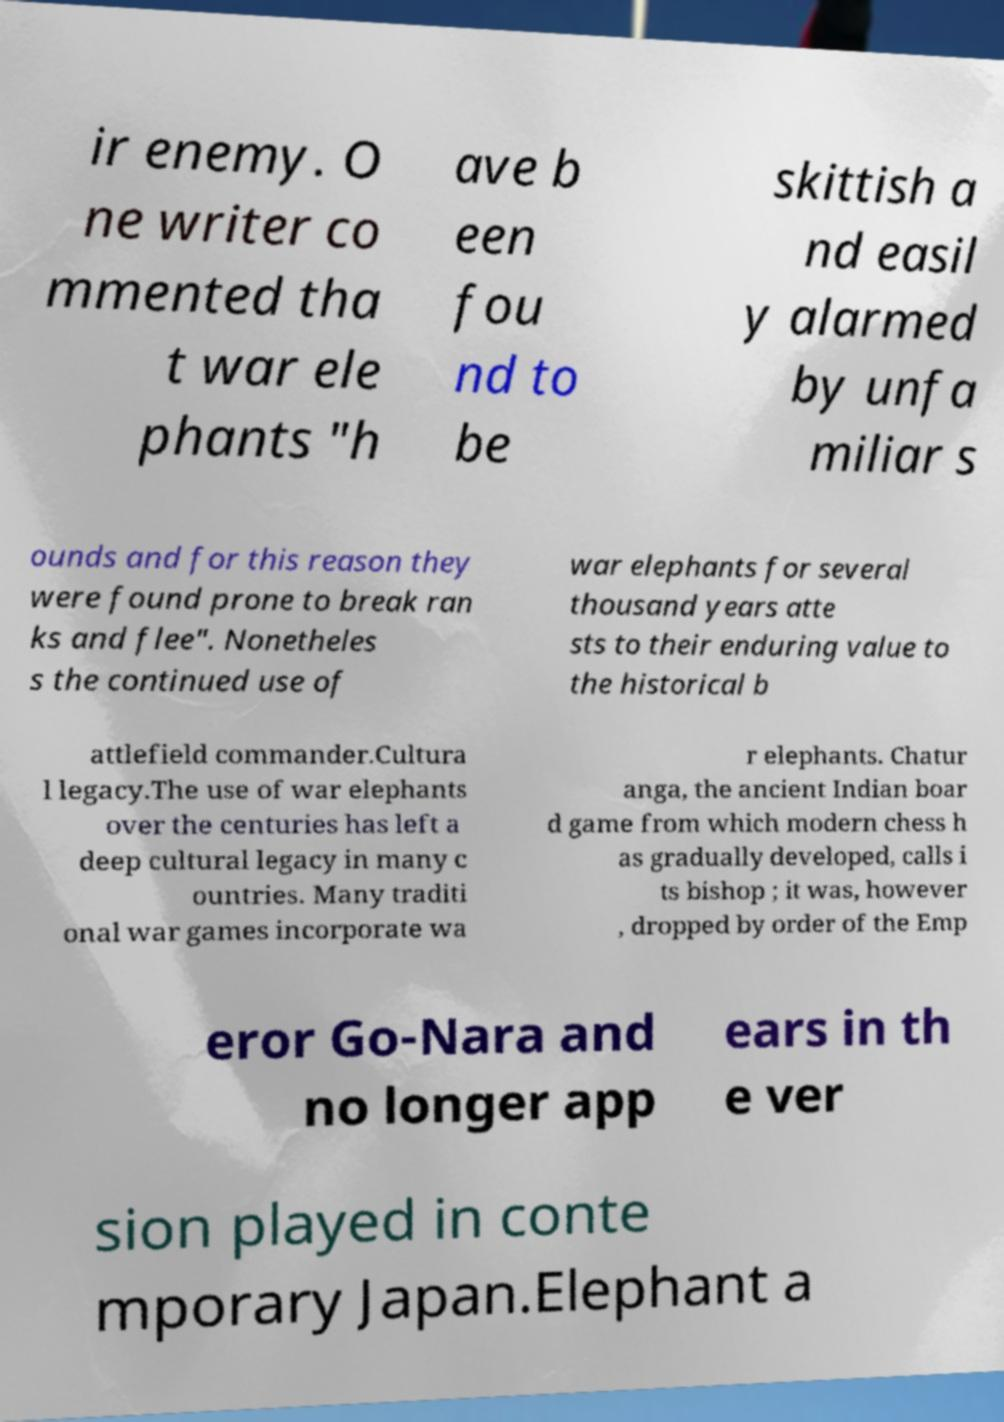Please read and relay the text visible in this image. What does it say? ir enemy. O ne writer co mmented tha t war ele phants "h ave b een fou nd to be skittish a nd easil y alarmed by unfa miliar s ounds and for this reason they were found prone to break ran ks and flee". Nonetheles s the continued use of war elephants for several thousand years atte sts to their enduring value to the historical b attlefield commander.Cultura l legacy.The use of war elephants over the centuries has left a deep cultural legacy in many c ountries. Many traditi onal war games incorporate wa r elephants. Chatur anga, the ancient Indian boar d game from which modern chess h as gradually developed, calls i ts bishop ; it was, however , dropped by order of the Emp eror Go-Nara and no longer app ears in th e ver sion played in conte mporary Japan.Elephant a 